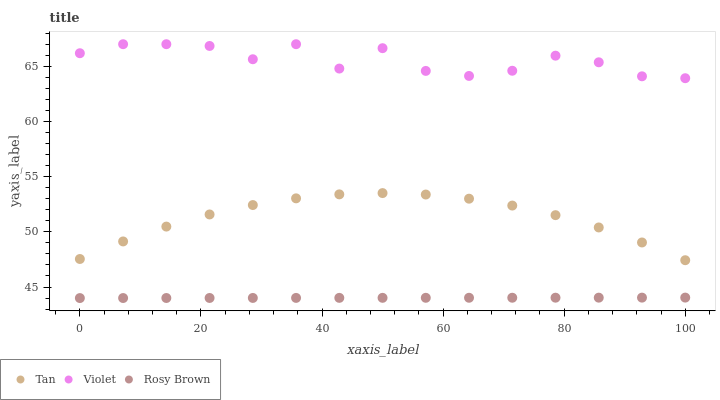Does Rosy Brown have the minimum area under the curve?
Answer yes or no. Yes. Does Violet have the maximum area under the curve?
Answer yes or no. Yes. Does Violet have the minimum area under the curve?
Answer yes or no. No. Does Rosy Brown have the maximum area under the curve?
Answer yes or no. No. Is Rosy Brown the smoothest?
Answer yes or no. Yes. Is Violet the roughest?
Answer yes or no. Yes. Is Violet the smoothest?
Answer yes or no. No. Is Rosy Brown the roughest?
Answer yes or no. No. Does Rosy Brown have the lowest value?
Answer yes or no. Yes. Does Violet have the lowest value?
Answer yes or no. No. Does Violet have the highest value?
Answer yes or no. Yes. Does Rosy Brown have the highest value?
Answer yes or no. No. Is Rosy Brown less than Violet?
Answer yes or no. Yes. Is Violet greater than Rosy Brown?
Answer yes or no. Yes. Does Rosy Brown intersect Violet?
Answer yes or no. No. 